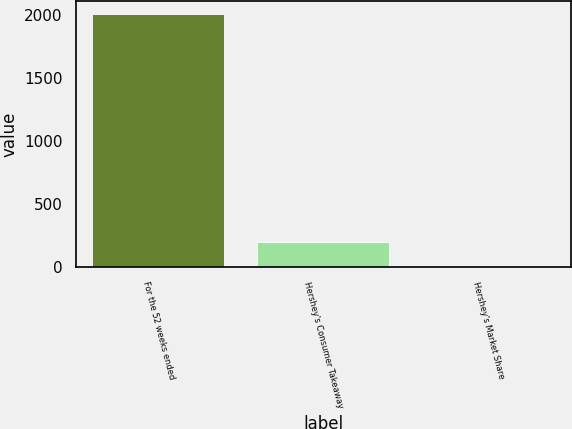Convert chart. <chart><loc_0><loc_0><loc_500><loc_500><bar_chart><fcel>For the 52 weeks ended<fcel>Hershey's Consumer Takeaway<fcel>Hershey's Market Share<nl><fcel>2015<fcel>201.59<fcel>0.1<nl></chart> 